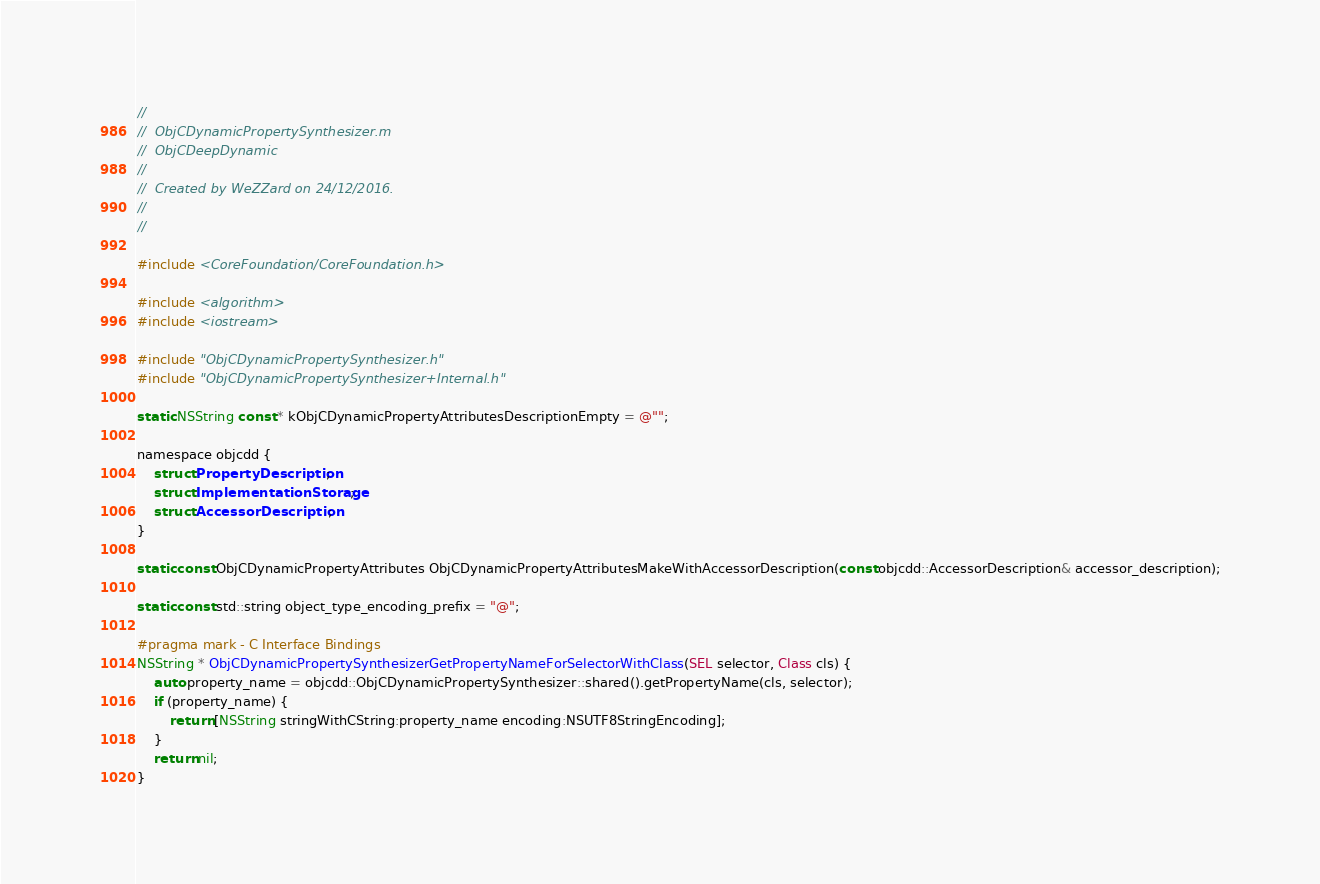Convert code to text. <code><loc_0><loc_0><loc_500><loc_500><_ObjectiveC_>//
//  ObjCDynamicPropertySynthesizer.m
//  ObjCDeepDynamic
//
//  Created by WeZZard on 24/12/2016.
//
//

#include <CoreFoundation/CoreFoundation.h>

#include <algorithm>
#include <iostream>

#include "ObjCDynamicPropertySynthesizer.h"
#include "ObjCDynamicPropertySynthesizer+Internal.h"

static NSString const * kObjCDynamicPropertyAttributesDescriptionEmpty = @"";

namespace objcdd {
    struct PropertyDescription;
    struct ImplementationStorage;
    struct AccessorDescription;
}

static const ObjCDynamicPropertyAttributes ObjCDynamicPropertyAttributesMakeWithAccessorDescription(const objcdd::AccessorDescription& accessor_description);

static const std::string object_type_encoding_prefix = "@";

#pragma mark - C Interface Bindings
NSString * ObjCDynamicPropertySynthesizerGetPropertyNameForSelectorWithClass(SEL selector, Class cls) {
    auto property_name = objcdd::ObjCDynamicPropertySynthesizer::shared().getPropertyName(cls, selector);
    if (property_name) {
        return [NSString stringWithCString:property_name encoding:NSUTF8StringEncoding];
    }
    return nil;
}
</code> 